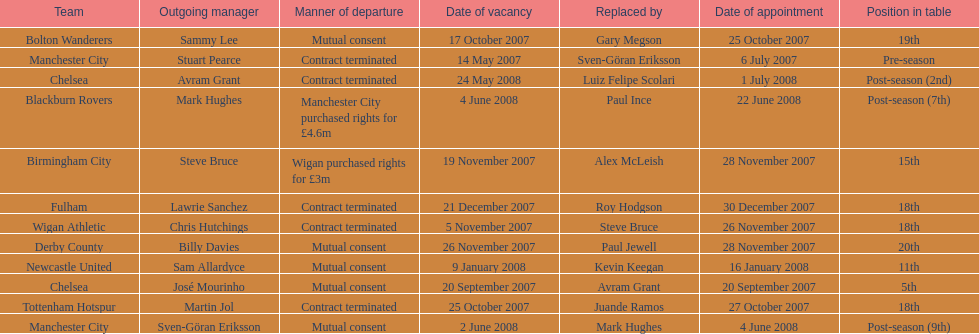Which team is positioned subsequent to manchester city? Chelsea. 